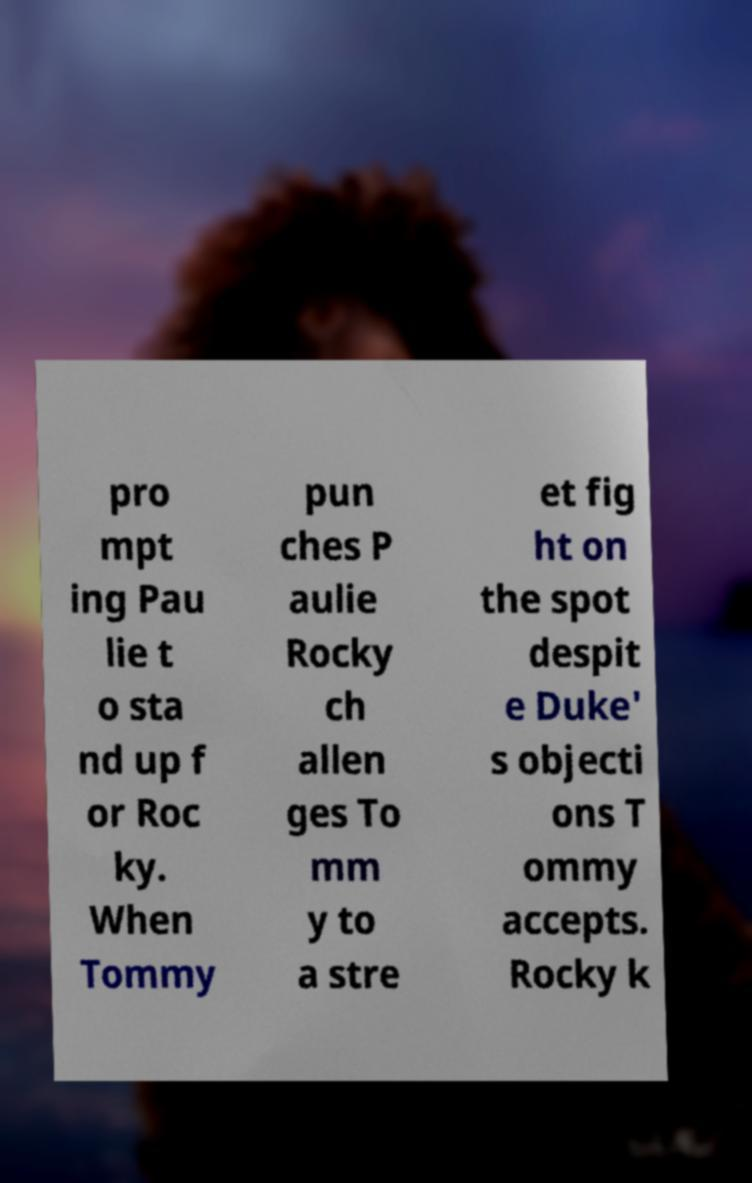Please read and relay the text visible in this image. What does it say? pro mpt ing Pau lie t o sta nd up f or Roc ky. When Tommy pun ches P aulie Rocky ch allen ges To mm y to a stre et fig ht on the spot despit e Duke' s objecti ons T ommy accepts. Rocky k 